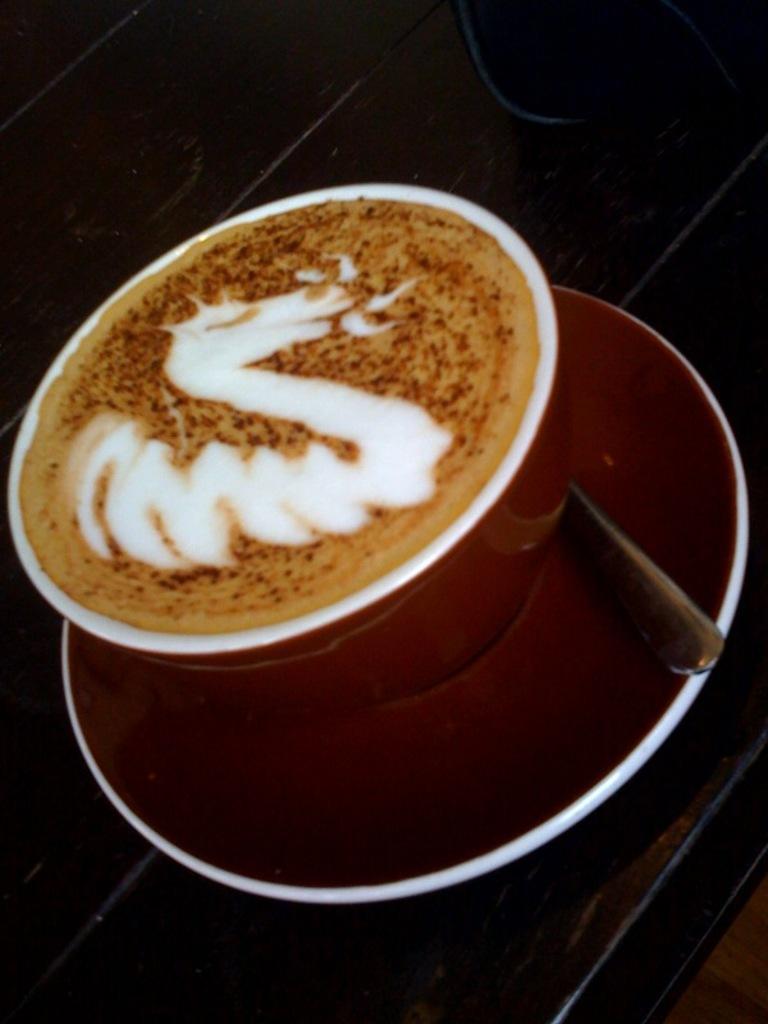In one or two sentences, can you explain what this image depicts? In this image we can see a cup, saucer and a spoon. Saucer is placed on a surface. In the cup we can see the drink. 